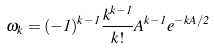<formula> <loc_0><loc_0><loc_500><loc_500>\omega _ { k } = ( - 1 ) ^ { k - 1 } \frac { k ^ { k - 1 } } { k ! } A ^ { k - 1 } e ^ { - k A / 2 }</formula> 